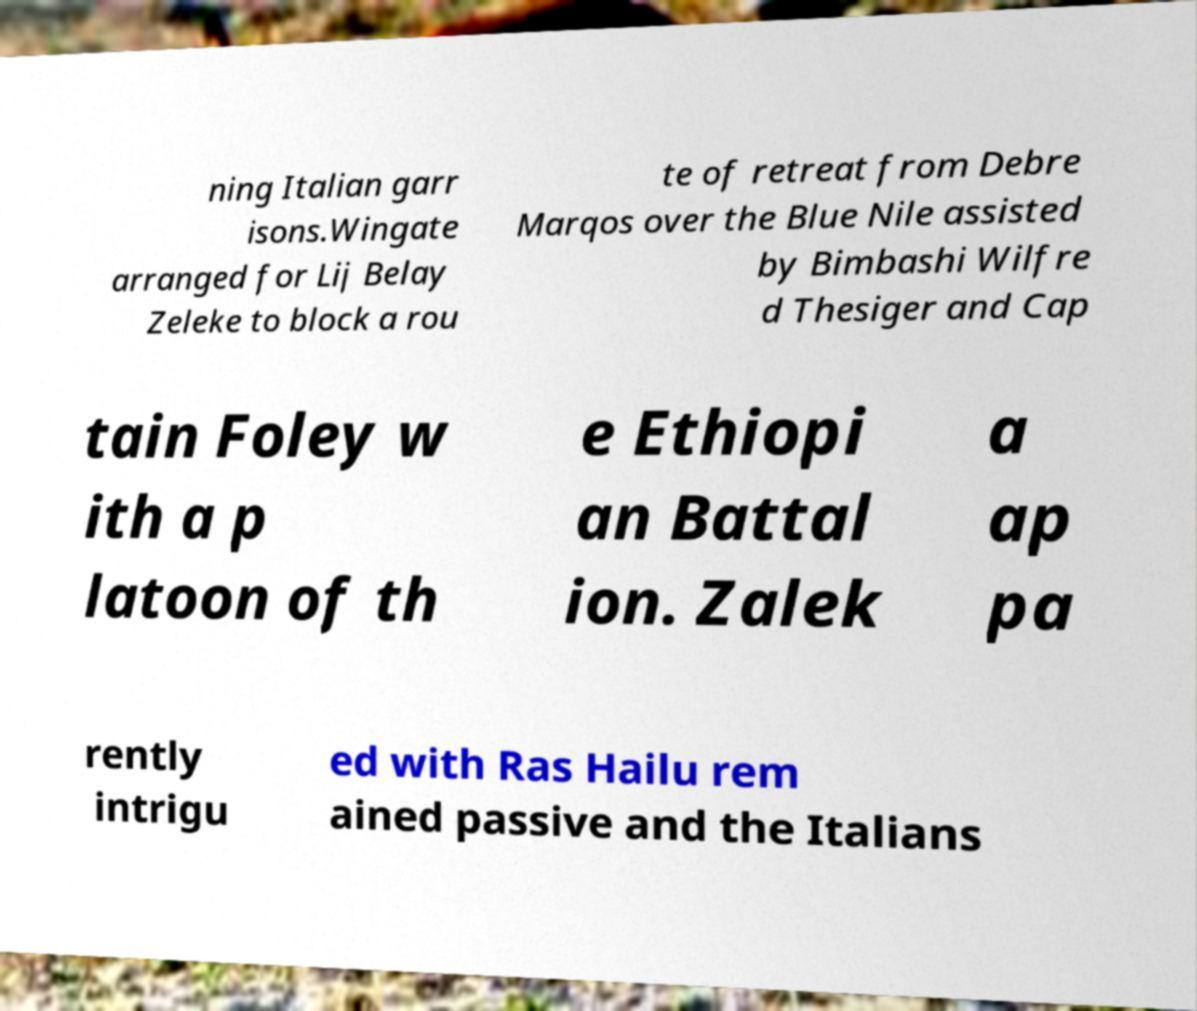There's text embedded in this image that I need extracted. Can you transcribe it verbatim? ning Italian garr isons.Wingate arranged for Lij Belay Zeleke to block a rou te of retreat from Debre Marqos over the Blue Nile assisted by Bimbashi Wilfre d Thesiger and Cap tain Foley w ith a p latoon of th e Ethiopi an Battal ion. Zalek a ap pa rently intrigu ed with Ras Hailu rem ained passive and the Italians 